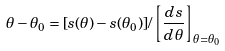Convert formula to latex. <formula><loc_0><loc_0><loc_500><loc_500>\theta - \theta _ { 0 } = [ s ( \theta ) - s ( \theta _ { 0 } ) ] / \left [ \frac { d s } { d \theta } \right ] _ { \theta = \theta _ { 0 } }</formula> 